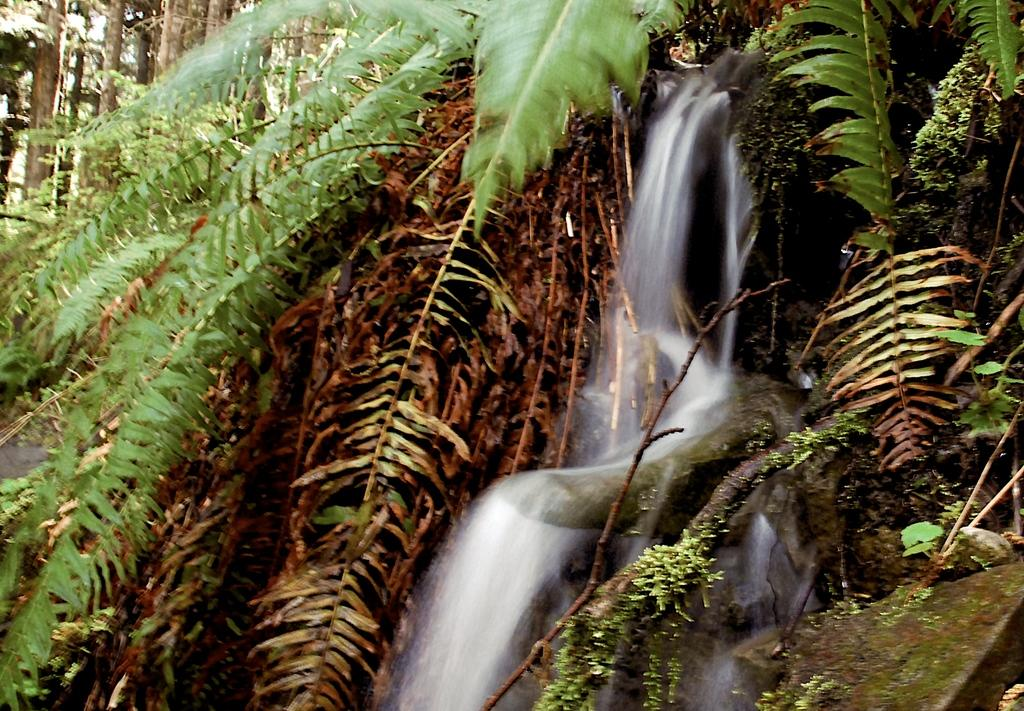What type of vegetation can be seen in the image? There are trees in the image. What part of the trees can be seen in the image? Leaves are present in the image. What natural element is visible in the image? There is water visible in the image. What type of geological formation is present in the image? Rocks are present in the image. How many roses can be seen in the image? There are no roses present in the image. What type of egg is visible in the image? There are no eggs present in the image. 